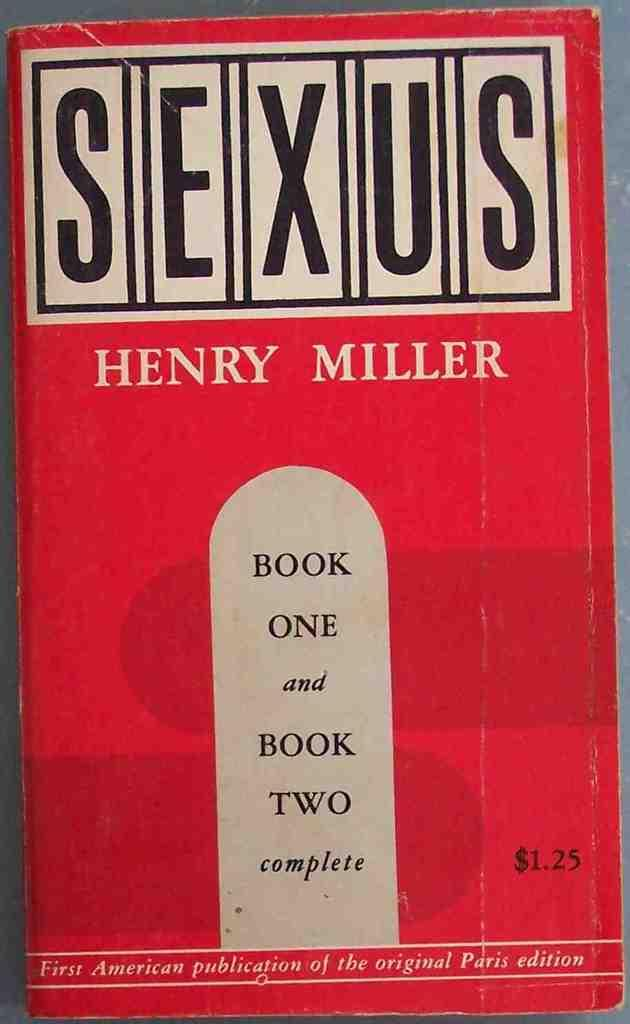Provide a one-sentence caption for the provided image. A red book called Sexus by Henry Miller has a $1.25 price tag. 